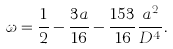Convert formula to latex. <formula><loc_0><loc_0><loc_500><loc_500>\omega = \frac { 1 } { 2 } - \frac { 3 a } { 1 6 } - \frac { 1 5 3 } { 1 6 } \frac { a ^ { 2 } } { D ^ { 4 } } .</formula> 